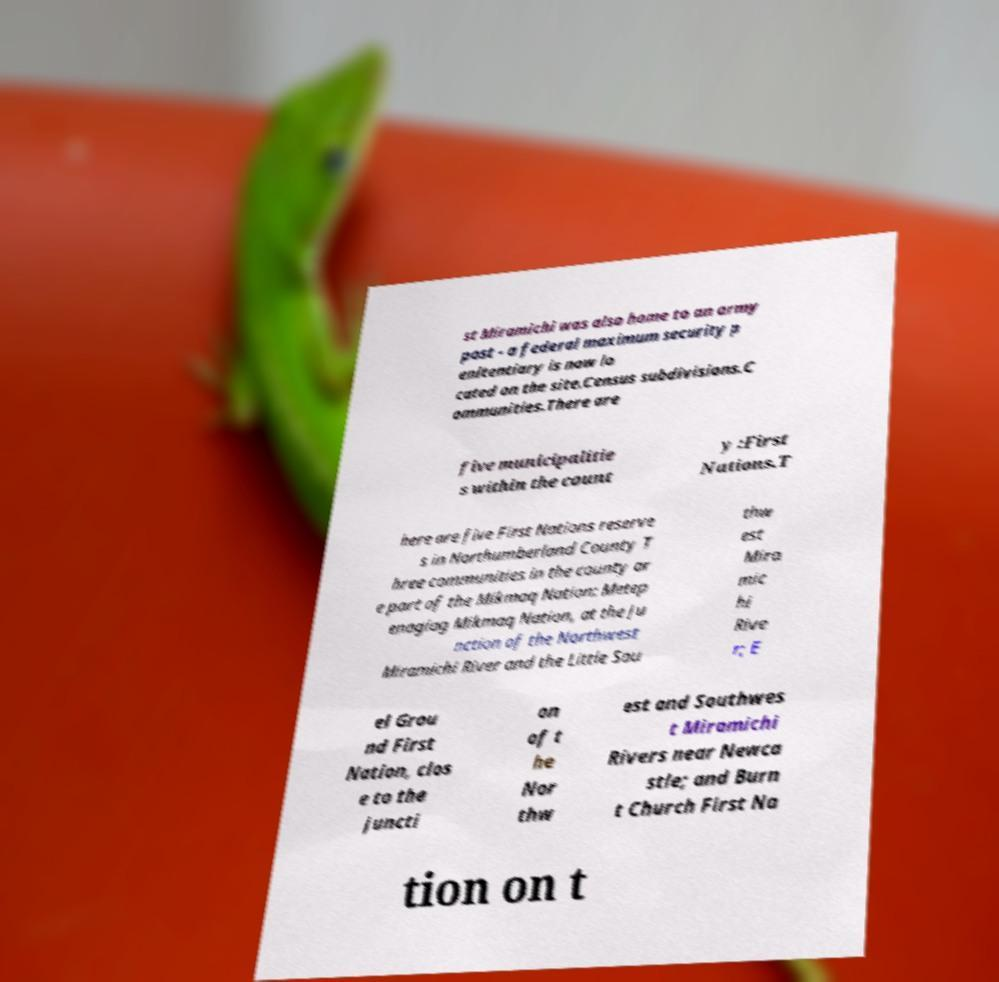Could you extract and type out the text from this image? st Miramichi was also home to an army post - a federal maximum security p enitentiary is now lo cated on the site.Census subdivisions.C ommunities.There are five municipalitie s within the count y :First Nations.T here are five First Nations reserve s in Northumberland County T hree communities in the county ar e part of the Mikmaq Nation: Metep enagiag Mikmaq Nation, at the ju nction of the Northwest Miramichi River and the Little Sou thw est Mira mic hi Rive r; E el Grou nd First Nation, clos e to the juncti on of t he Nor thw est and Southwes t Miramichi Rivers near Newca stle; and Burn t Church First Na tion on t 